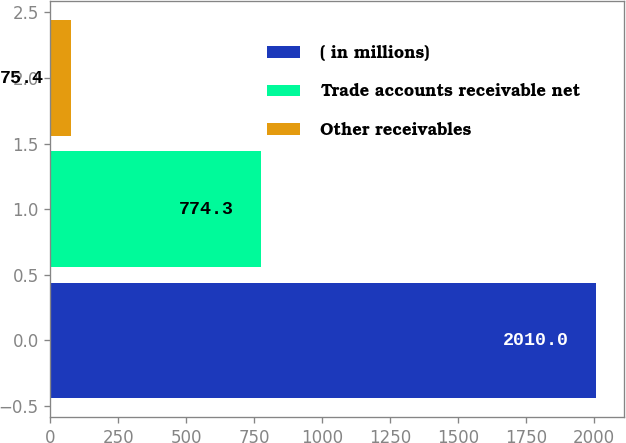<chart> <loc_0><loc_0><loc_500><loc_500><bar_chart><fcel>( in millions)<fcel>Trade accounts receivable net<fcel>Other receivables<nl><fcel>2010<fcel>774.3<fcel>75.4<nl></chart> 